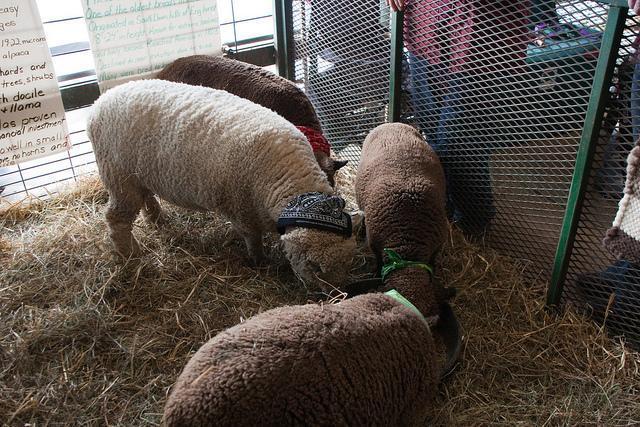How many sheep are there?
Give a very brief answer. 4. 